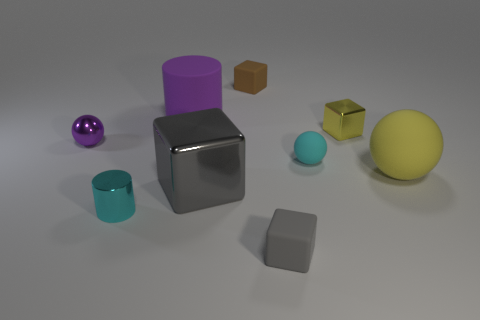Can you describe the texture of the objects and how they might feel to touch? The objects in the image vary in texture: the purple and silver cubes appear smooth and metallic, whereas the brown cube looks rough and grainy, reminiscent of cardboard. The spheres and the cyan cylinder have a matte finish that suggests a soft and even texture, providing a tactile contrast to the hard metallic surfaces. 